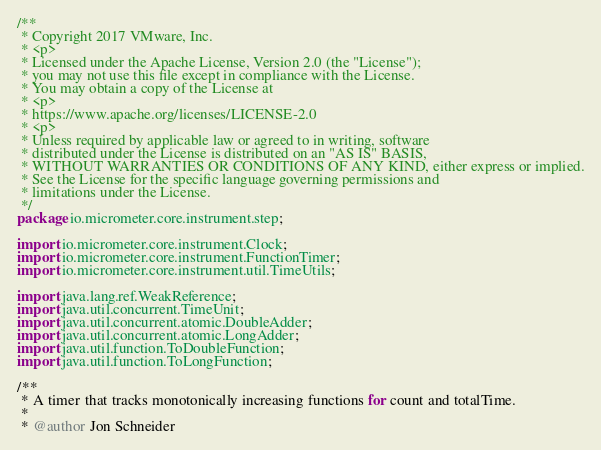<code> <loc_0><loc_0><loc_500><loc_500><_Java_>/**
 * Copyright 2017 VMware, Inc.
 * <p>
 * Licensed under the Apache License, Version 2.0 (the "License");
 * you may not use this file except in compliance with the License.
 * You may obtain a copy of the License at
 * <p>
 * https://www.apache.org/licenses/LICENSE-2.0
 * <p>
 * Unless required by applicable law or agreed to in writing, software
 * distributed under the License is distributed on an "AS IS" BASIS,
 * WITHOUT WARRANTIES OR CONDITIONS OF ANY KIND, either express or implied.
 * See the License for the specific language governing permissions and
 * limitations under the License.
 */
package io.micrometer.core.instrument.step;

import io.micrometer.core.instrument.Clock;
import io.micrometer.core.instrument.FunctionTimer;
import io.micrometer.core.instrument.util.TimeUtils;

import java.lang.ref.WeakReference;
import java.util.concurrent.TimeUnit;
import java.util.concurrent.atomic.DoubleAdder;
import java.util.concurrent.atomic.LongAdder;
import java.util.function.ToDoubleFunction;
import java.util.function.ToLongFunction;

/**
 * A timer that tracks monotonically increasing functions for count and totalTime.
 *
 * @author Jon Schneider</code> 